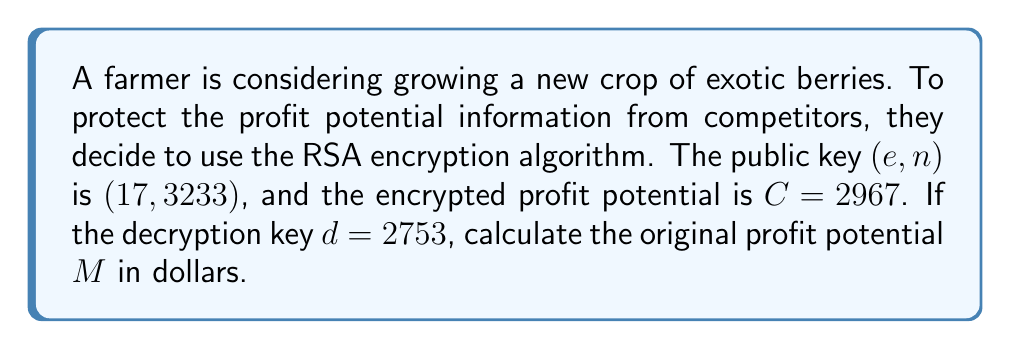Help me with this question. To solve this problem, we need to use the RSA decryption formula:

$$M \equiv C^d \pmod{n}$$

Where:
$M$ is the original message (profit potential)
$C$ is the ciphertext (encrypted profit potential)
$d$ is the private decryption key
$n$ is the modulus

Step 1: Substitute the given values into the formula
$$M \equiv 2967^{2753} \pmod{3233}$$

Step 2: Use the modular exponentiation algorithm to efficiently compute this large number
We can use the square-and-multiply algorithm:

$2967^1 \equiv 2967 \pmod{3233}$
$2967^2 \equiv 1600 \pmod{3233}$
$2967^4 \equiv 1531 \pmod{3233}$
$2967^8 \equiv 2809 \pmod{3233}$
$2967^{16} \equiv 2401 \pmod{3233}$
...

Continuing this process and combining the results according to the binary representation of 2753, we get:

$$M \equiv 1250 \pmod{3233}$$

Step 3: Interpret the result
The decrypted value 1250 represents the profit potential in dollars.
Answer: $1250 